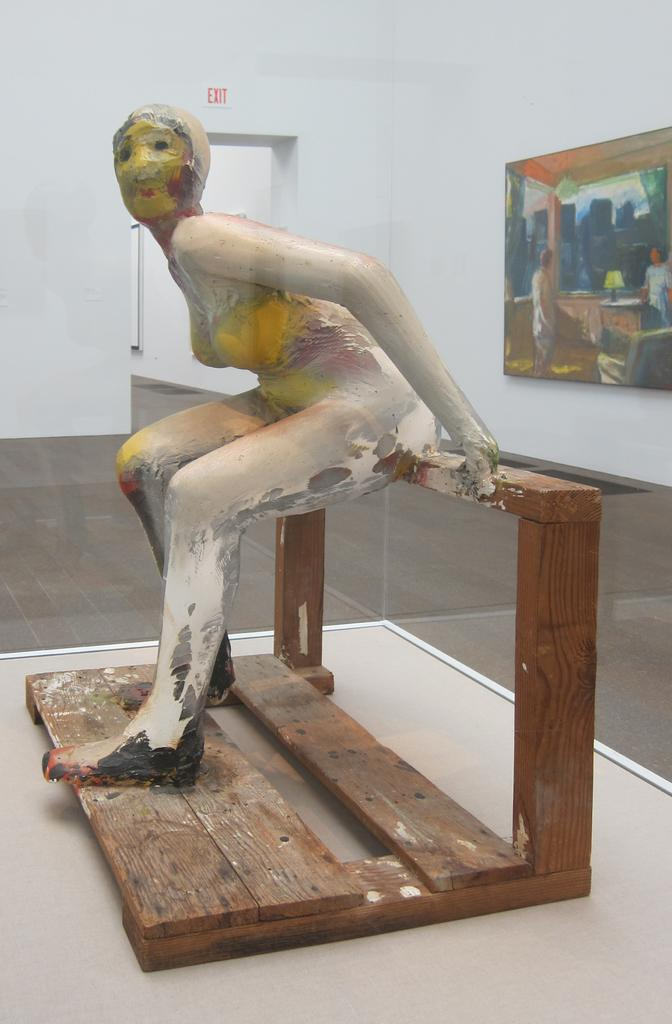What is the main subject on the wooden board in the image? There is a statue on a wooden board in the image. What can be seen on the wall in the image? There are photo frames and an exit board on the wall in the image. What is visible at the bottom of the image? The floor is visible at the bottom of the image. What type of discussion is taking place between the ducks in the image? There are no ducks present in the image, so there cannot be a discussion between them. 